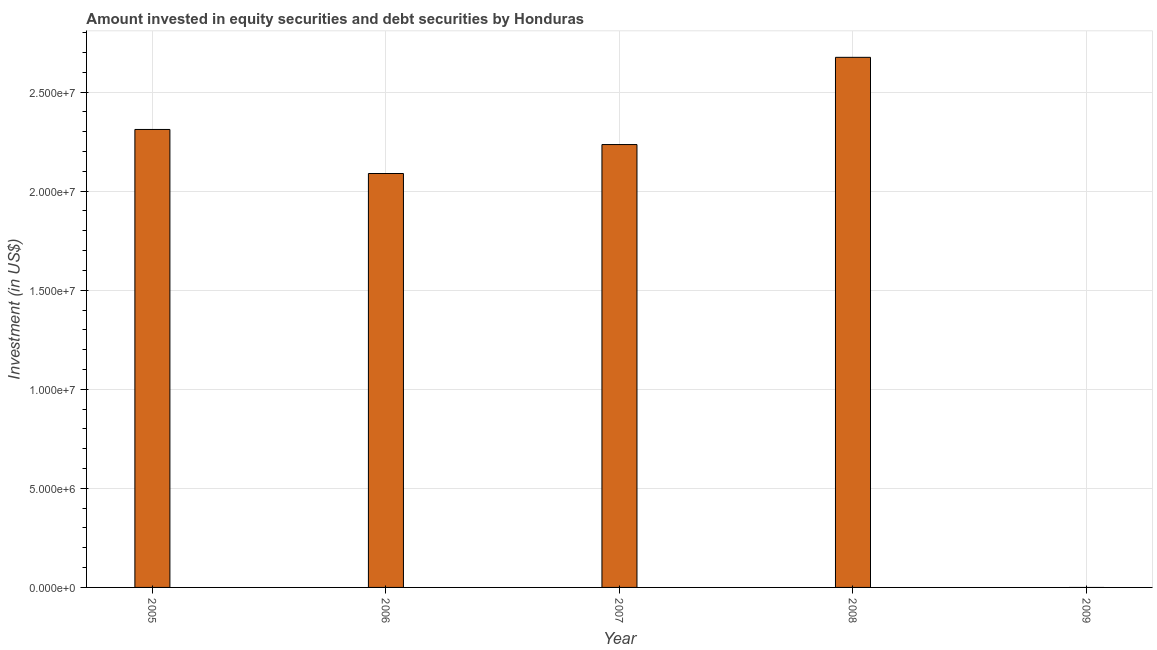What is the title of the graph?
Give a very brief answer. Amount invested in equity securities and debt securities by Honduras. What is the label or title of the Y-axis?
Your answer should be very brief. Investment (in US$). What is the portfolio investment in 2007?
Ensure brevity in your answer.  2.24e+07. Across all years, what is the maximum portfolio investment?
Offer a terse response. 2.68e+07. What is the sum of the portfolio investment?
Ensure brevity in your answer.  9.31e+07. What is the difference between the portfolio investment in 2005 and 2006?
Your answer should be very brief. 2.22e+06. What is the average portfolio investment per year?
Your response must be concise. 1.86e+07. What is the median portfolio investment?
Give a very brief answer. 2.24e+07. What is the ratio of the portfolio investment in 2006 to that in 2007?
Your response must be concise. 0.94. What is the difference between the highest and the second highest portfolio investment?
Provide a succinct answer. 3.64e+06. What is the difference between the highest and the lowest portfolio investment?
Provide a succinct answer. 2.68e+07. How many years are there in the graph?
Give a very brief answer. 5. Are the values on the major ticks of Y-axis written in scientific E-notation?
Keep it short and to the point. Yes. What is the Investment (in US$) of 2005?
Provide a short and direct response. 2.31e+07. What is the Investment (in US$) of 2006?
Offer a terse response. 2.09e+07. What is the Investment (in US$) in 2007?
Offer a very short reply. 2.24e+07. What is the Investment (in US$) in 2008?
Ensure brevity in your answer.  2.68e+07. What is the Investment (in US$) of 2009?
Give a very brief answer. 0. What is the difference between the Investment (in US$) in 2005 and 2006?
Provide a succinct answer. 2.22e+06. What is the difference between the Investment (in US$) in 2005 and 2007?
Offer a very short reply. 7.62e+05. What is the difference between the Investment (in US$) in 2005 and 2008?
Make the answer very short. -3.64e+06. What is the difference between the Investment (in US$) in 2006 and 2007?
Make the answer very short. -1.46e+06. What is the difference between the Investment (in US$) in 2006 and 2008?
Ensure brevity in your answer.  -5.86e+06. What is the difference between the Investment (in US$) in 2007 and 2008?
Offer a very short reply. -4.40e+06. What is the ratio of the Investment (in US$) in 2005 to that in 2006?
Provide a short and direct response. 1.11. What is the ratio of the Investment (in US$) in 2005 to that in 2007?
Provide a short and direct response. 1.03. What is the ratio of the Investment (in US$) in 2005 to that in 2008?
Provide a short and direct response. 0.86. What is the ratio of the Investment (in US$) in 2006 to that in 2007?
Keep it short and to the point. 0.94. What is the ratio of the Investment (in US$) in 2006 to that in 2008?
Give a very brief answer. 0.78. What is the ratio of the Investment (in US$) in 2007 to that in 2008?
Give a very brief answer. 0.83. 